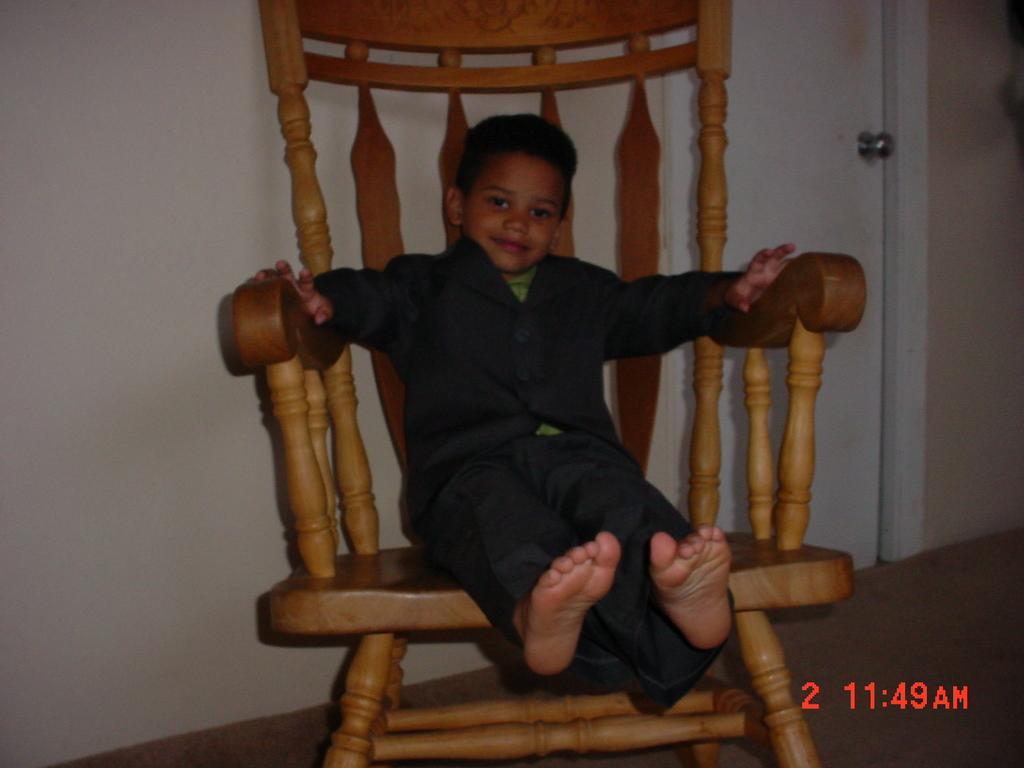How would you summarize this image in a sentence or two? In this image In the middle there is a chair on that there is a boy he wears trouser, t shirt. In the background there is a wall and door. 